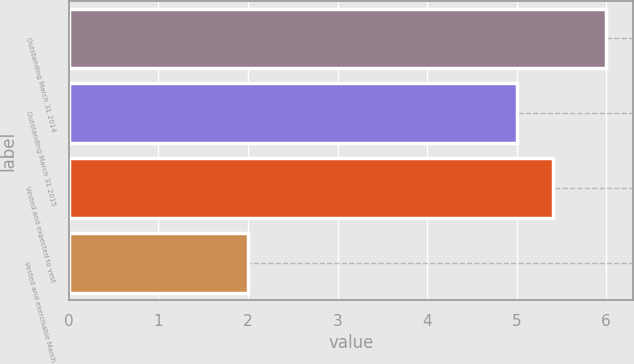Convert chart to OTSL. <chart><loc_0><loc_0><loc_500><loc_500><bar_chart><fcel>Outstanding March 31 2014<fcel>Outstanding March 31 2015<fcel>Vested and expected to vest<fcel>Vested and exercisable March<nl><fcel>6<fcel>5<fcel>5.4<fcel>2<nl></chart> 